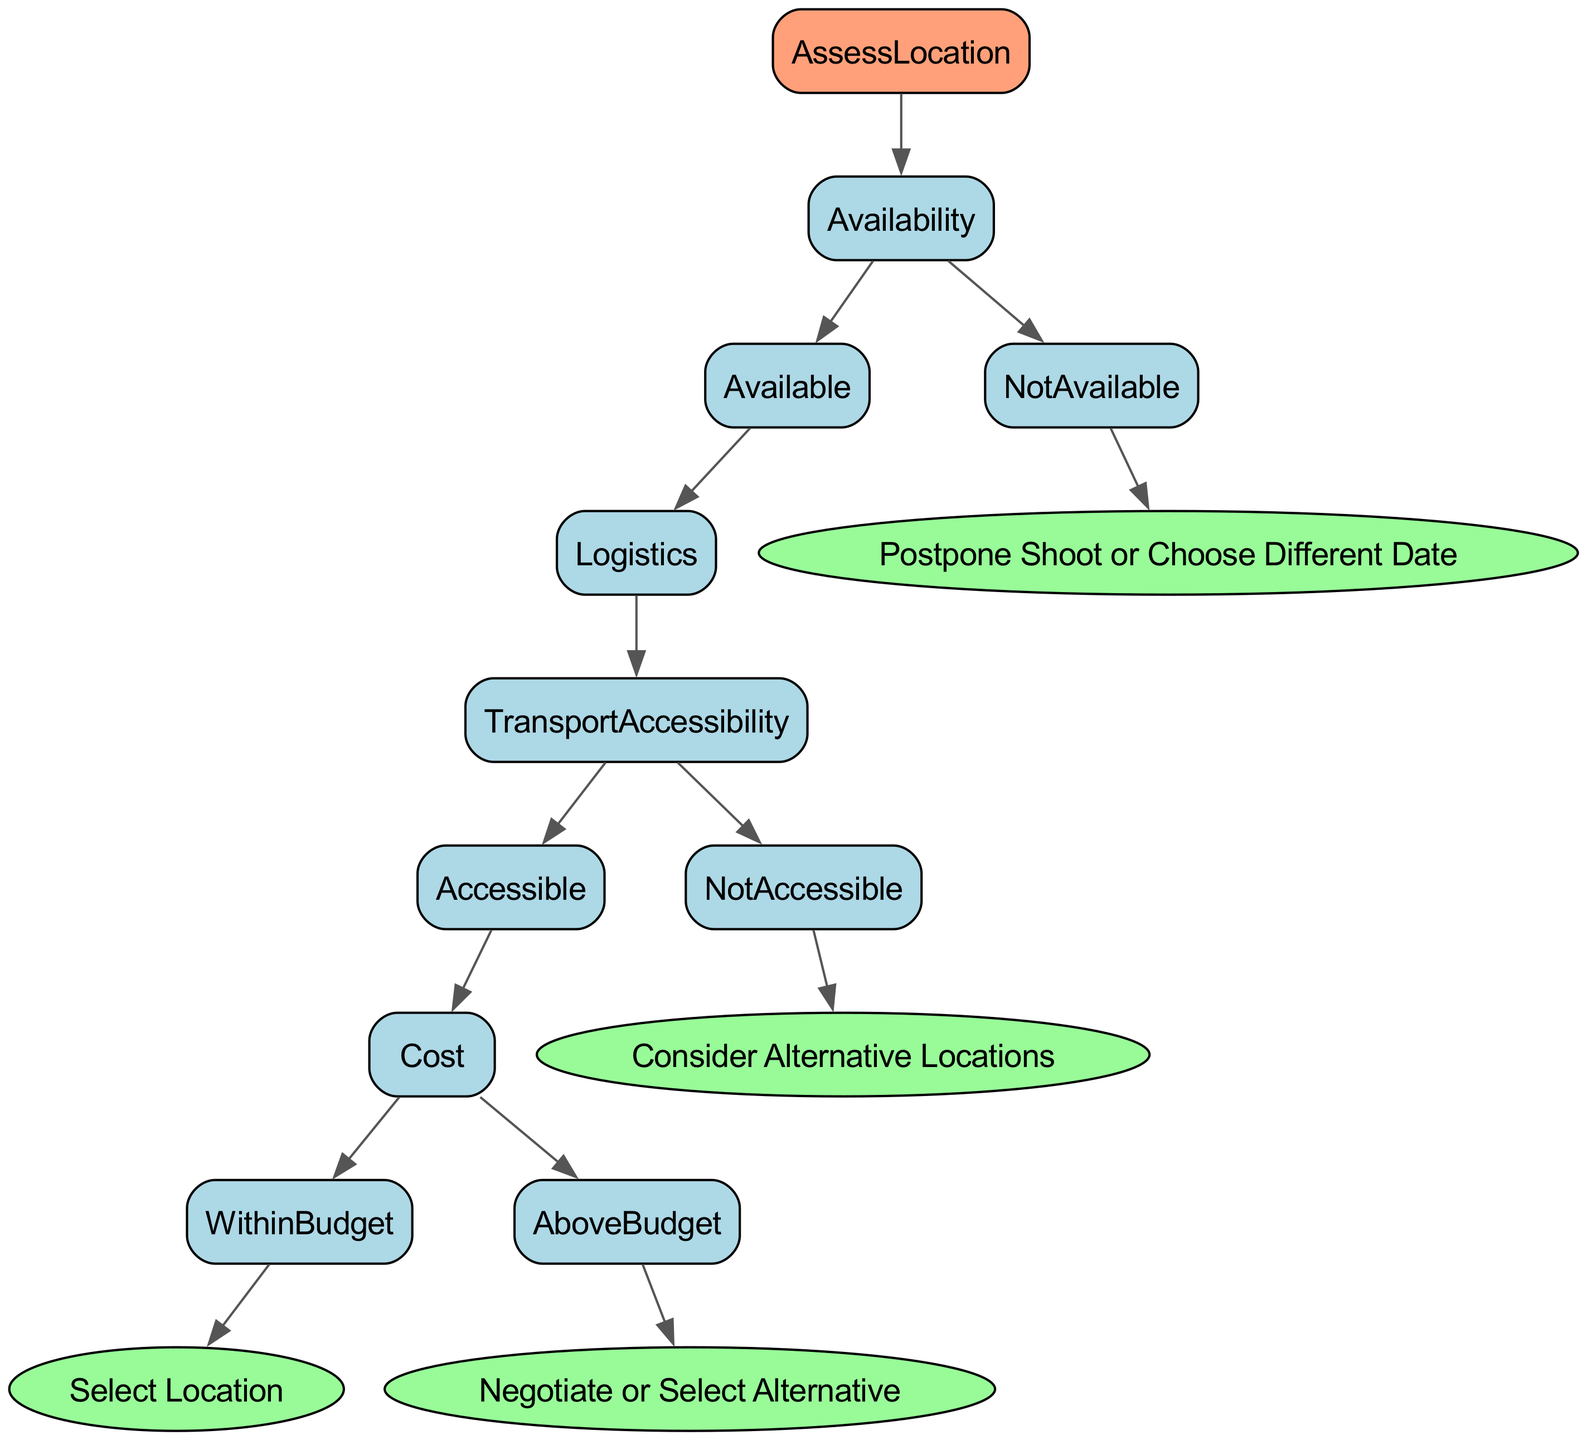What is the first decision point in the diagram? The first decision point in the diagram is to assess the availability of the location. This is the first branch that determines the path taken through the decision tree.
Answer: Availability What happens if the location is not available? If the location is not available, the decision tree directs towards postponing the shoot or choosing a different date. This outcome clearly states the action required when the availability condition fails.
Answer: Postpone Shoot or Choose Different Date How many outcomes are possible if the location is available? If the location is available, the decision tree leads to two distinct paths: evaluating logistics and then assessing costs. Additionally, there are two outcomes at the cost assessment stage, leading to overall four potential outcomes.
Answer: Four What is the outcome if transport accessibility is not accessible? If transport accessibility is determined to be not accessible, the tree indicates considering alternative locations. This shows a direct result from the logistics evaluation stage.
Answer: Consider Alternative Locations What is the final decision if the cost is above budget? If the cost is above budget, the final decision indicated by the diagram is to negotiate or select an alternative location, which provides a clear action in response to budget constraints.
Answer: Negotiate or Select Alternative What must be fulfilled for the decision to select a location? To decide to select a location, both logistics have to be accessible, and the cost must be within the budget. This highlights the necessary conditions before a selection can be made.
Answer: Accessible Transport and Within Budget What follows after assessing logistics if the location is available? After assessing logistics, if transport accessibility is found to be accessible, the next step is to evaluate the cost associated with the location. This reflects the sequence of decisions leading to a final selection or alternative actions.
Answer: Evaluate Cost What does the diagram indicate about negotiating? The diagram indicates that negotiating is an option only if the cost is above budget after assessing that the location is available and transport accessibility is adequate. This indicates a fallback plan when financial constraints are encountered.
Answer: Negotiate 